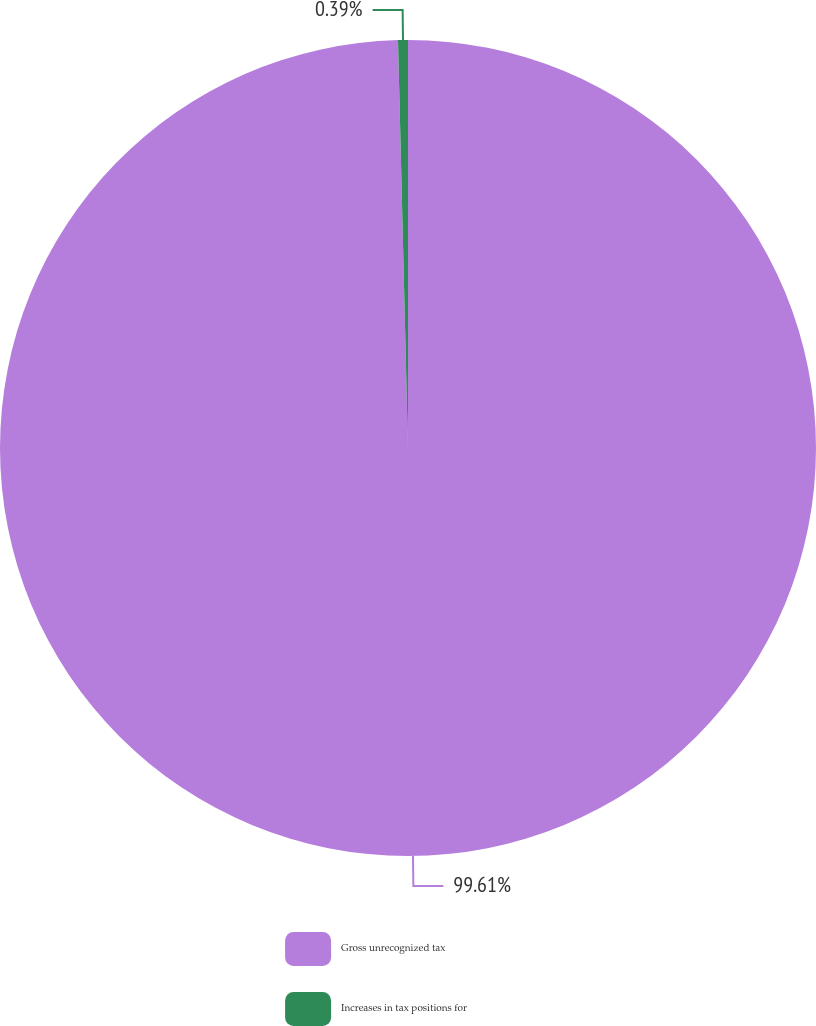<chart> <loc_0><loc_0><loc_500><loc_500><pie_chart><fcel>Gross unrecognized tax<fcel>Increases in tax positions for<nl><fcel>99.61%<fcel>0.39%<nl></chart> 